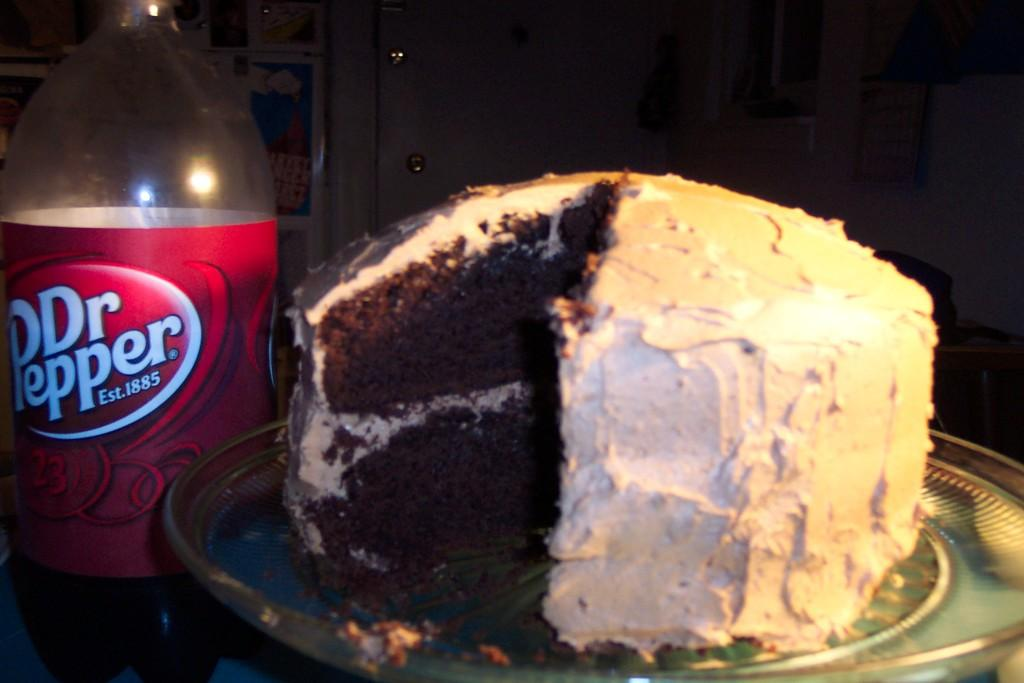What is on the plate that is visible in the image? There is a plate with cake in the image. What else can be seen on the plate or near it? There is a bottle with a sticker on it in the image. Can you describe the background of the image? The background of the image is dark. What type of island can be seen in the background of the image? There is no island present in the image; the background is dark. What texture can be felt on the drawer in the image? There is no drawer present in the image. 